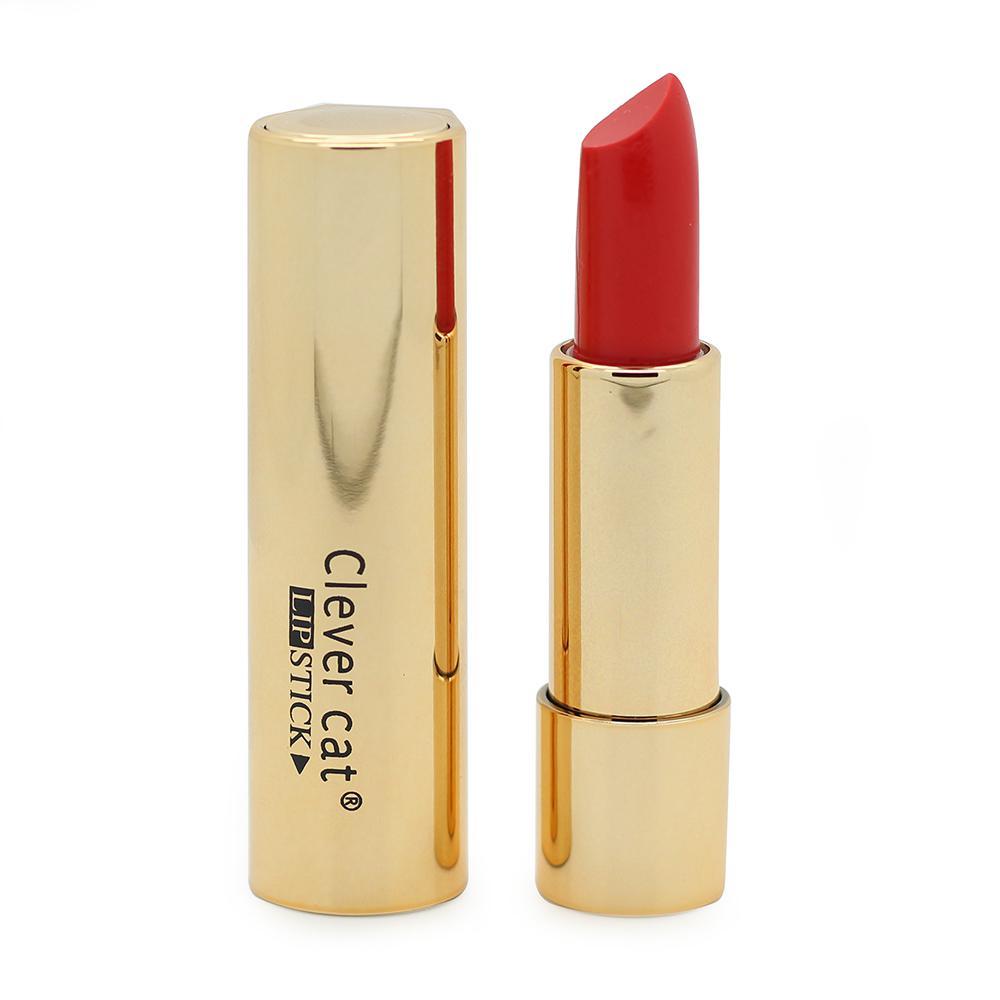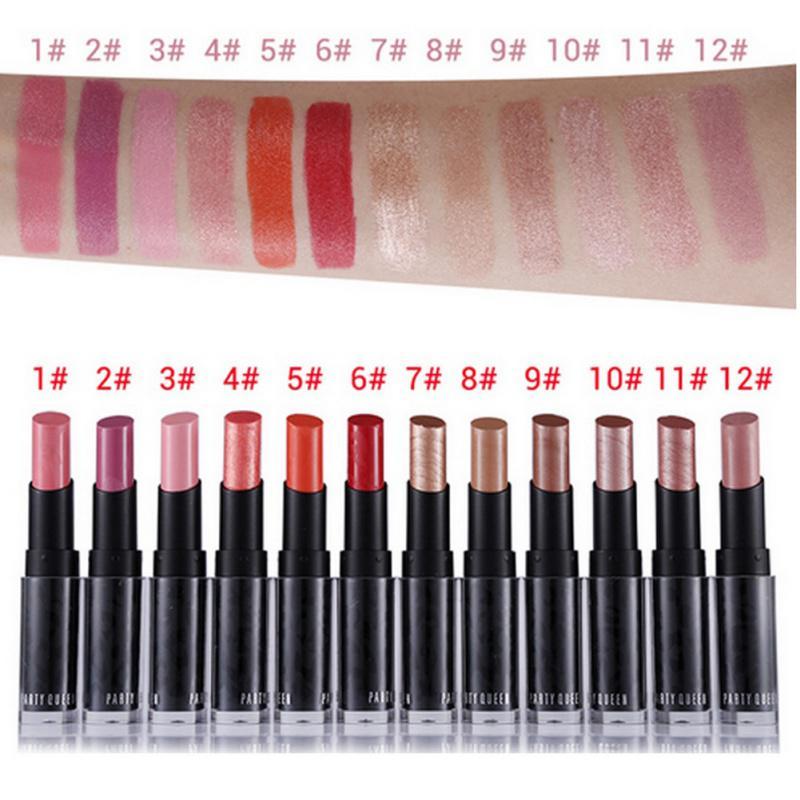The first image is the image on the left, the second image is the image on the right. For the images displayed, is the sentence "One image contains exactly two colors of lipstick." factually correct? Answer yes or no. No. 